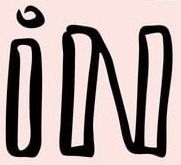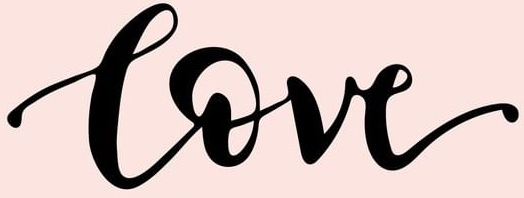Identify the words shown in these images in order, separated by a semicolon. iN; Love 